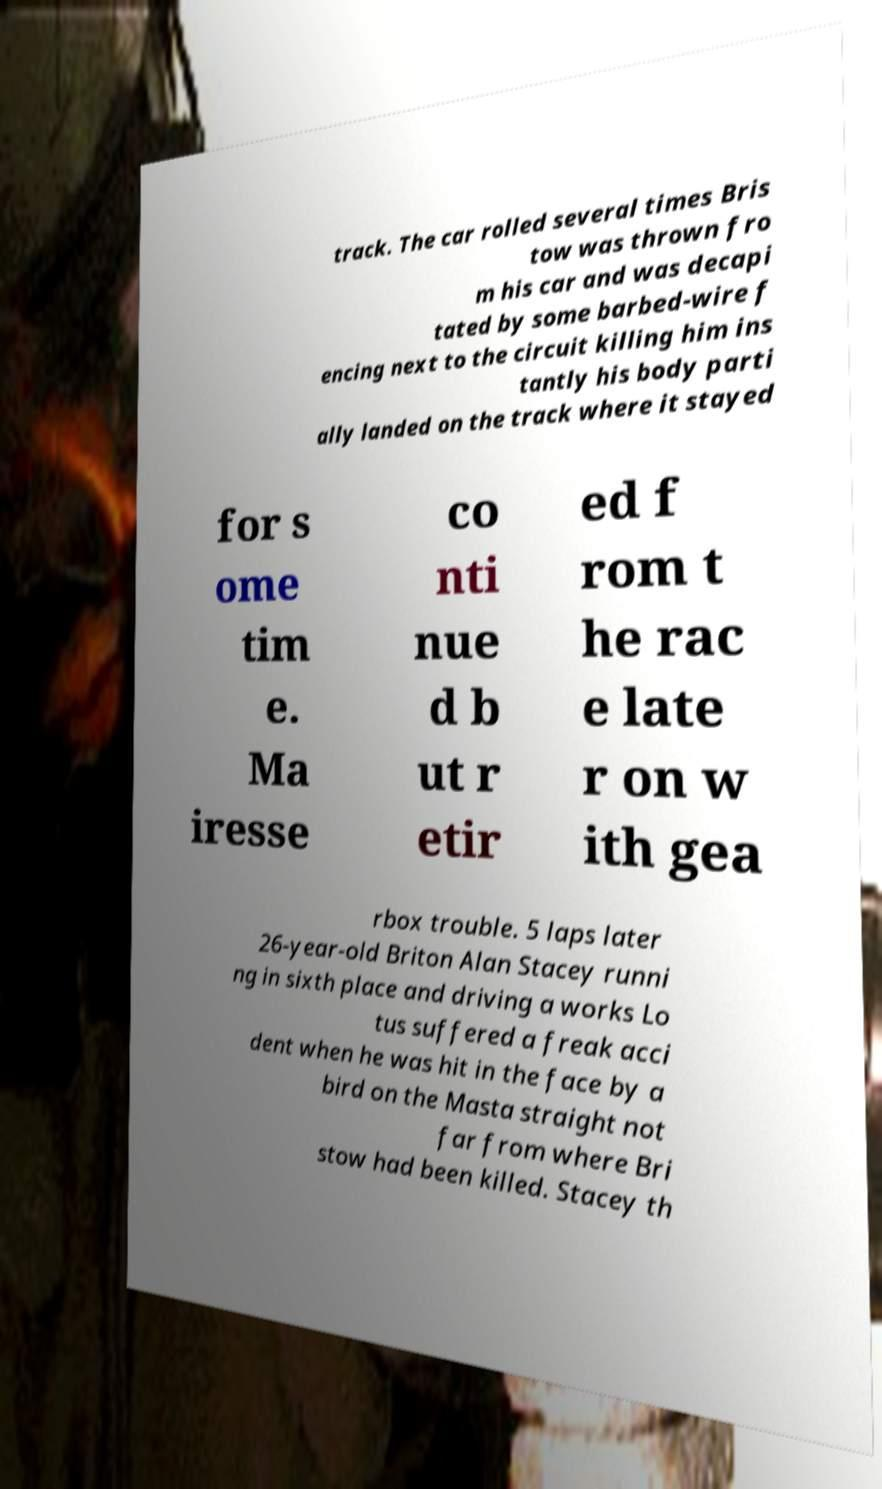I need the written content from this picture converted into text. Can you do that? track. The car rolled several times Bris tow was thrown fro m his car and was decapi tated by some barbed-wire f encing next to the circuit killing him ins tantly his body parti ally landed on the track where it stayed for s ome tim e. Ma iresse co nti nue d b ut r etir ed f rom t he rac e late r on w ith gea rbox trouble. 5 laps later 26-year-old Briton Alan Stacey runni ng in sixth place and driving a works Lo tus suffered a freak acci dent when he was hit in the face by a bird on the Masta straight not far from where Bri stow had been killed. Stacey th 